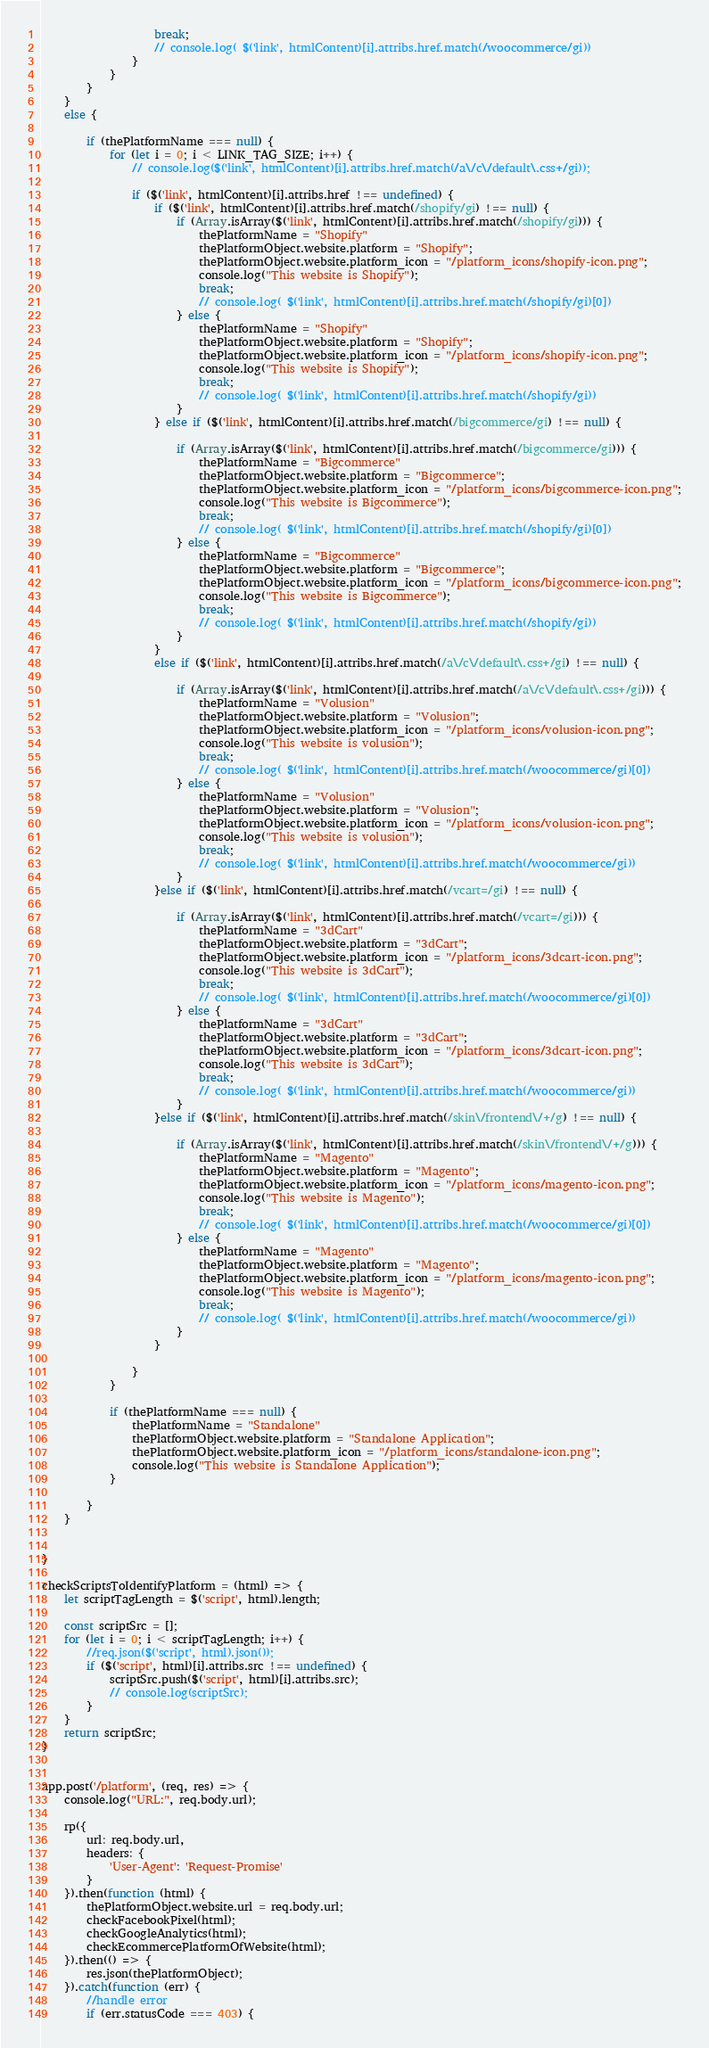Convert code to text. <code><loc_0><loc_0><loc_500><loc_500><_JavaScript_>                    break;
                    // console.log( $('link', htmlContent)[i].attribs.href.match(/woocommerce/gi))
                }
            }
        }
    }
    else {
        
        if (thePlatformName === null) {
            for (let i = 0; i < LINK_TAG_SIZE; i++) {
                // console.log($('link', htmlContent)[i].attribs.href.match(/a\/c\/default\.css+/gi));
                
                if ($('link', htmlContent)[i].attribs.href !== undefined) {
                    if ($('link', htmlContent)[i].attribs.href.match(/shopify/gi) !== null) {
                        if (Array.isArray($('link', htmlContent)[i].attribs.href.match(/shopify/gi))) {
                            thePlatformName = "Shopify"
                            thePlatformObject.website.platform = "Shopify";
                            thePlatformObject.website.platform_icon = "/platform_icons/shopify-icon.png";
                            console.log("This website is Shopify");
                            break;
                            // console.log( $('link', htmlContent)[i].attribs.href.match(/shopify/gi)[0])
                        } else {
                            thePlatformName = "Shopify"
                            thePlatformObject.website.platform = "Shopify";
                            thePlatformObject.website.platform_icon = "/platform_icons/shopify-icon.png";
                            console.log("This website is Shopify");
                            break;
                            // console.log( $('link', htmlContent)[i].attribs.href.match(/shopify/gi))
                        }
                    } else if ($('link', htmlContent)[i].attribs.href.match(/bigcommerce/gi) !== null) {
    
                        if (Array.isArray($('link', htmlContent)[i].attribs.href.match(/bigcommerce/gi))) {
                            thePlatformName = "Bigcommerce"
                            thePlatformObject.website.platform = "Bigcommerce";
                            thePlatformObject.website.platform_icon = "/platform_icons/bigcommerce-icon.png";
                            console.log("This website is Bigcommerce");
                            break;
                            // console.log( $('link', htmlContent)[i].attribs.href.match(/shopify/gi)[0])
                        } else {
                            thePlatformName = "Bigcommerce"
                            thePlatformObject.website.platform = "Bigcommerce";
                            thePlatformObject.website.platform_icon = "/platform_icons/bigcommerce-icon.png";
                            console.log("This website is Bigcommerce");
                            break;
                            // console.log( $('link', htmlContent)[i].attribs.href.match(/shopify/gi))
                        }
                    }
                    else if ($('link', htmlContent)[i].attribs.href.match(/a\/c\/default\.css+/gi) !== null) {
    
                        if (Array.isArray($('link', htmlContent)[i].attribs.href.match(/a\/c\/default\.css+/gi))) {
                            thePlatformName = "Volusion"
                            thePlatformObject.website.platform = "Volusion";
                            thePlatformObject.website.platform_icon = "/platform_icons/volusion-icon.png";
                            console.log("This website is volusion");
                            break;
                            // console.log( $('link', htmlContent)[i].attribs.href.match(/woocommerce/gi)[0])
                        } else {
                            thePlatformName = "Volusion"
                            thePlatformObject.website.platform = "Volusion";
                            thePlatformObject.website.platform_icon = "/platform_icons/volusion-icon.png";
                            console.log("This website is volusion");
                            break;
                            // console.log( $('link', htmlContent)[i].attribs.href.match(/woocommerce/gi))
                        }
                    }else if ($('link', htmlContent)[i].attribs.href.match(/vcart=/gi) !== null) {
    
                        if (Array.isArray($('link', htmlContent)[i].attribs.href.match(/vcart=/gi))) {
                            thePlatformName = "3dCart"
                            thePlatformObject.website.platform = "3dCart";
                            thePlatformObject.website.platform_icon = "/platform_icons/3dcart-icon.png";
                            console.log("This website is 3dCart");
                            break;
                            // console.log( $('link', htmlContent)[i].attribs.href.match(/woocommerce/gi)[0])
                        } else {
                            thePlatformName = "3dCart"
                            thePlatformObject.website.platform = "3dCart";
                            thePlatformObject.website.platform_icon = "/platform_icons/3dcart-icon.png";
                            console.log("This website is 3dCart");
                            break;
                            // console.log( $('link', htmlContent)[i].attribs.href.match(/woocommerce/gi))
                        }
                    }else if ($('link', htmlContent)[i].attribs.href.match(/skin\/frontend\/+/g) !== null) {
    
                        if (Array.isArray($('link', htmlContent)[i].attribs.href.match(/skin\/frontend\/+/g))) {
                            thePlatformName = "Magento"
                            thePlatformObject.website.platform = "Magento";
                            thePlatformObject.website.platform_icon = "/platform_icons/magento-icon.png";
                            console.log("This website is Magento");
                            break;
                            // console.log( $('link', htmlContent)[i].attribs.href.match(/woocommerce/gi)[0])
                        } else {
                            thePlatformName = "Magento"
                            thePlatformObject.website.platform = "Magento";
                            thePlatformObject.website.platform_icon = "/platform_icons/magento-icon.png";
                            console.log("This website is Magento");
                            break;
                            // console.log( $('link', htmlContent)[i].attribs.href.match(/woocommerce/gi))
                        }
                    }
                    
                }
            }
    
            if (thePlatformName === null) {
                thePlatformName = "Standalone"
                thePlatformObject.website.platform = "Standalone Application";
                thePlatformObject.website.platform_icon = "/platform_icons/standalone-icon.png";
                console.log("This website is Standalone Application");
            }
            
        }
    }


}

checkScriptsToIdentifyPlatform = (html) => {
    let scriptTagLength = $('script', html).length;

    const scriptSrc = [];
    for (let i = 0; i < scriptTagLength; i++) {
        //req.json($('script', html).json());
        if ($('script', html)[i].attribs.src !== undefined) {
            scriptSrc.push($('script', html)[i].attribs.src);
            // console.log(scriptSrc);
        }
    }
    return scriptSrc;
}


app.post('/platform', (req, res) => {
    console.log("URL:", req.body.url);

    rp({
        url: req.body.url,
        headers: {
            'User-Agent': 'Request-Promise'
        }
    }).then(function (html) {
        thePlatformObject.website.url = req.body.url;
        checkFacebookPixel(html);
        checkGoogleAnalytics(html);
        checkEcommercePlatformOfWebsite(html);
    }).then(() => {
        res.json(thePlatformObject);
    }).catch(function (err) {
        //handle error
        if (err.statusCode === 403) {</code> 